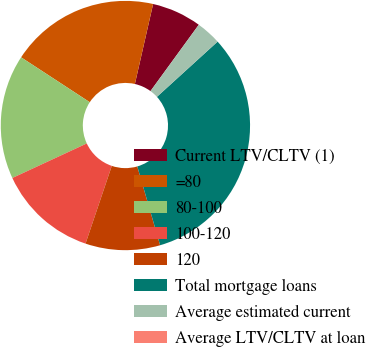<chart> <loc_0><loc_0><loc_500><loc_500><pie_chart><fcel>Current LTV/CLTV (1)<fcel>=80<fcel>80-100<fcel>100-120<fcel>120<fcel>Total mortgage loans<fcel>Average estimated current<fcel>Average LTV/CLTV at loan<nl><fcel>6.45%<fcel>19.35%<fcel>16.13%<fcel>12.9%<fcel>9.68%<fcel>32.26%<fcel>3.23%<fcel>0.0%<nl></chart> 